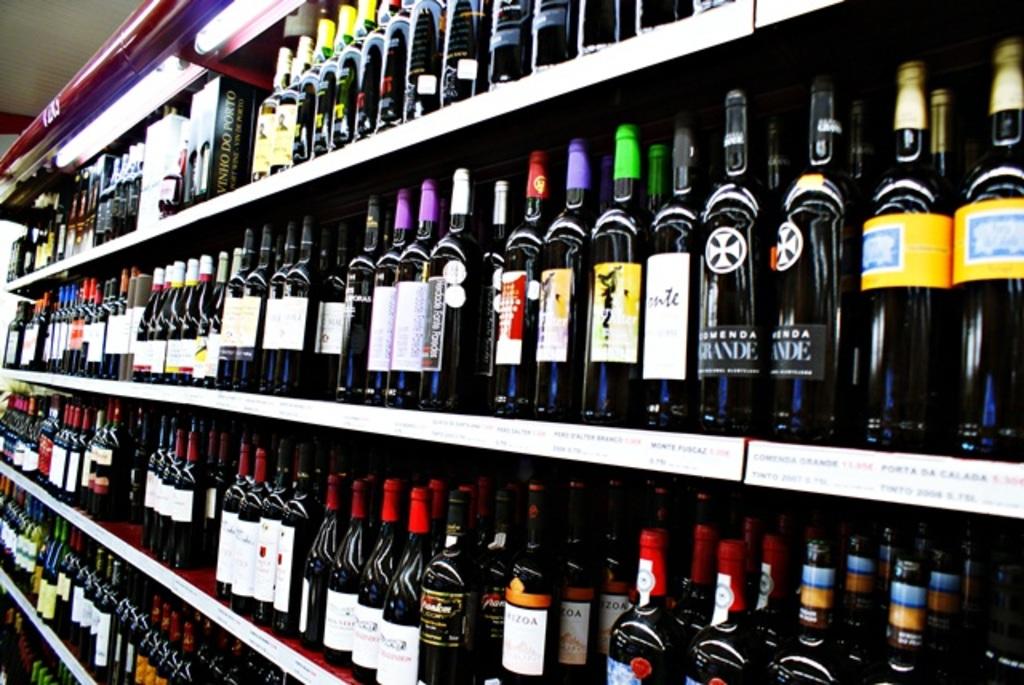Is all of that wine?
Provide a succinct answer. Yes. 